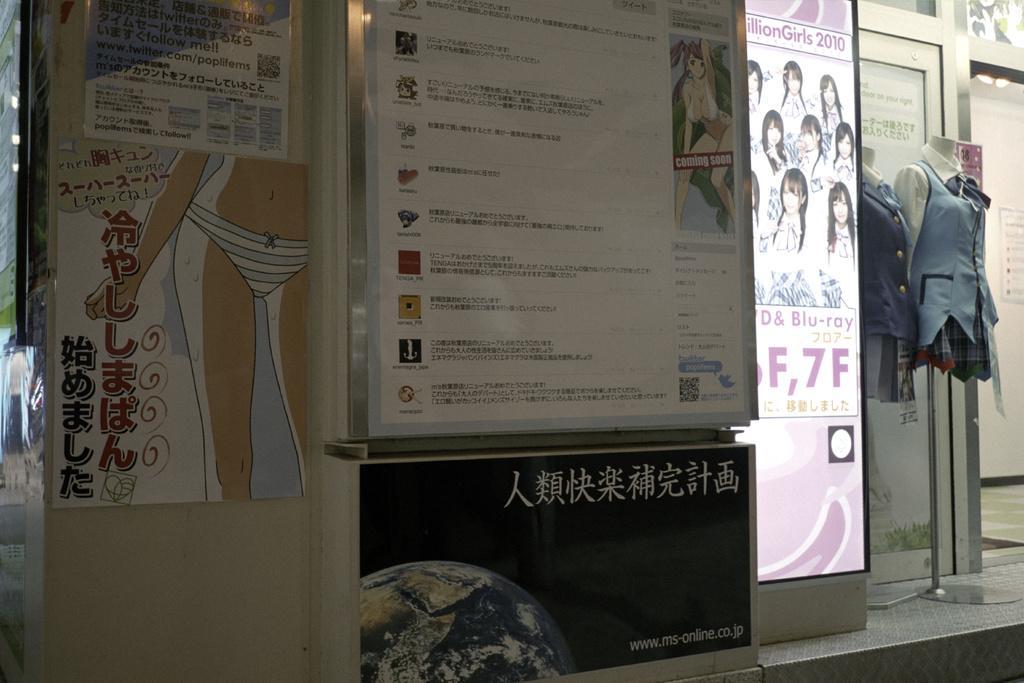Can you describe this image briefly? This picture shows a store and we see posters on it and we see couple of Mannequins with clothes on them for the display. 